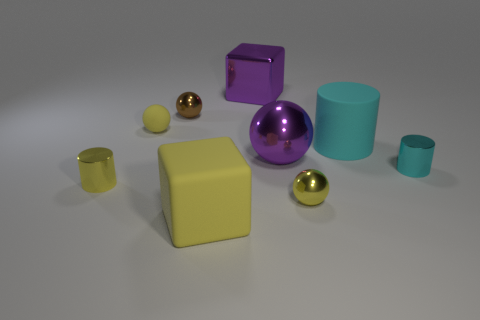Is the number of spheres less than the number of gray things?
Give a very brief answer. No. What is the color of the thing that is both to the left of the large yellow matte thing and behind the small yellow rubber thing?
Provide a succinct answer. Brown. What is the material of the yellow thing that is the same shape as the tiny cyan metal object?
Make the answer very short. Metal. Is the number of yellow matte blocks greater than the number of tiny metal things?
Provide a short and direct response. No. There is a shiny sphere that is both behind the small yellow cylinder and right of the large purple cube; what is its size?
Offer a very short reply. Large. What is the shape of the large cyan rubber thing?
Give a very brief answer. Cylinder. How many big objects are the same shape as the small cyan thing?
Provide a succinct answer. 1. Are there fewer big cyan matte objects that are in front of the purple shiny sphere than purple metallic cubes that are behind the tiny brown shiny ball?
Your answer should be compact. Yes. How many cylinders are on the right side of the yellow thing left of the yellow matte sphere?
Offer a terse response. 2. Are any brown cubes visible?
Give a very brief answer. No. 